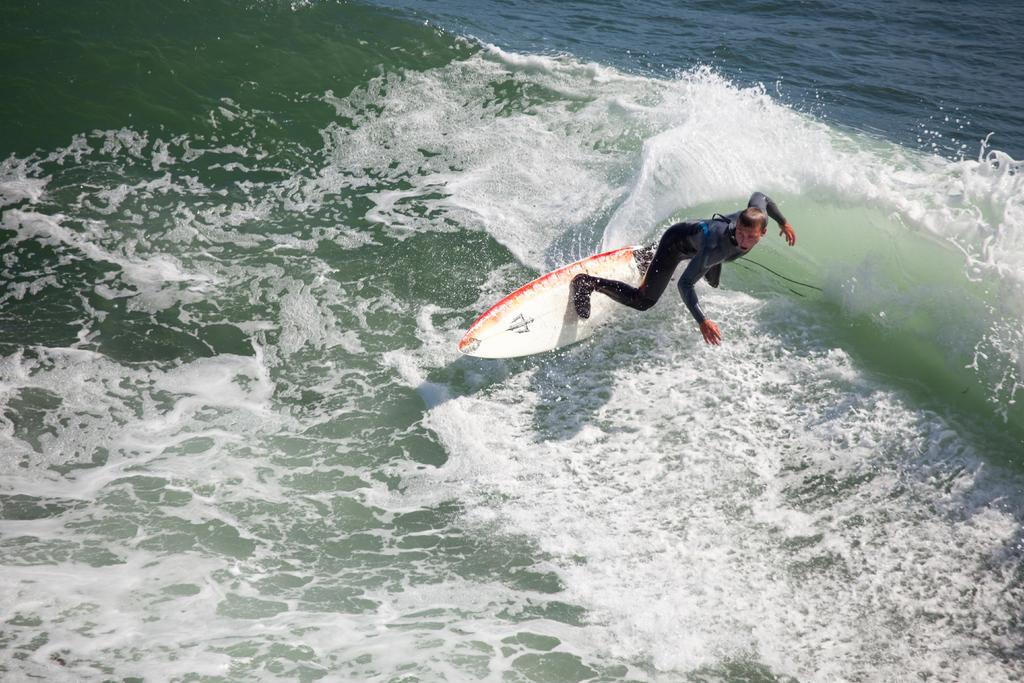Please provide a concise description of this image. Here I can see the water and a person is wearing black color dress and surfing the board on the water. 